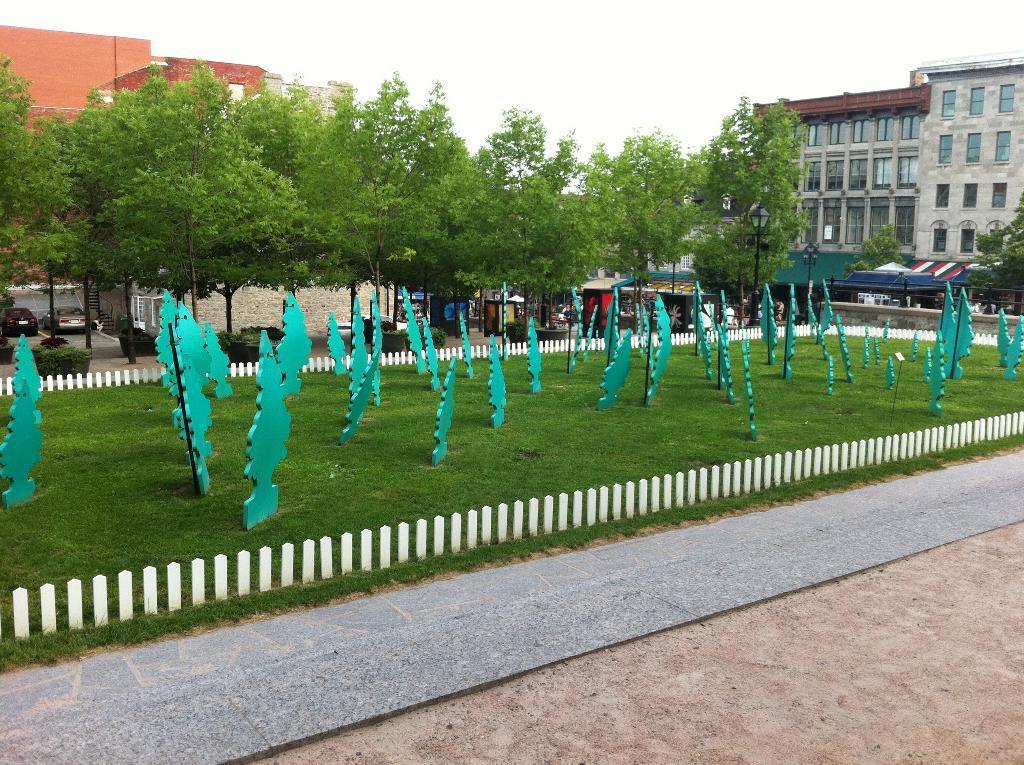Please provide a concise description of this image. At the bottom, we see the pavement and the sand. In the middle, we see the picket fence, grass, poles and the boards in green color. There are trees, buildings and poles in the background. We see the tents of the buildings in blue, green and red color and we see the cars parked on the road. At the top, we see the sky. 